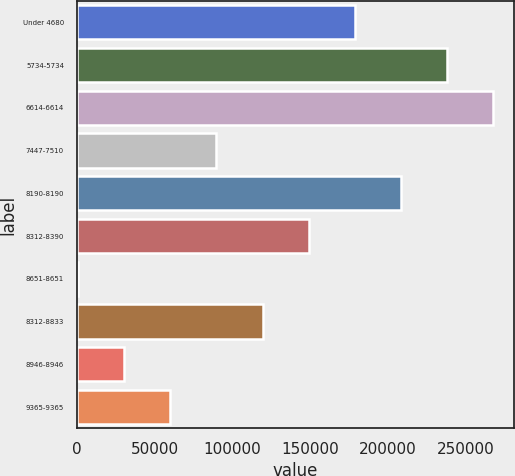Convert chart. <chart><loc_0><loc_0><loc_500><loc_500><bar_chart><fcel>Under 4680<fcel>5734-5734<fcel>6614-6614<fcel>7447-7510<fcel>8190-8190<fcel>8312-8390<fcel>8651-8651<fcel>8312-8833<fcel>8946-8946<fcel>9365-9365<nl><fcel>178712<fcel>238116<fcel>267818<fcel>89606<fcel>208414<fcel>149010<fcel>500<fcel>119308<fcel>30202<fcel>59904<nl></chart> 